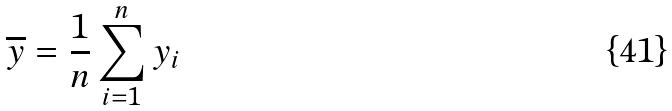<formula> <loc_0><loc_0><loc_500><loc_500>\overline { y } = \frac { 1 } { n } \sum _ { i = 1 } ^ { n } y _ { i }</formula> 